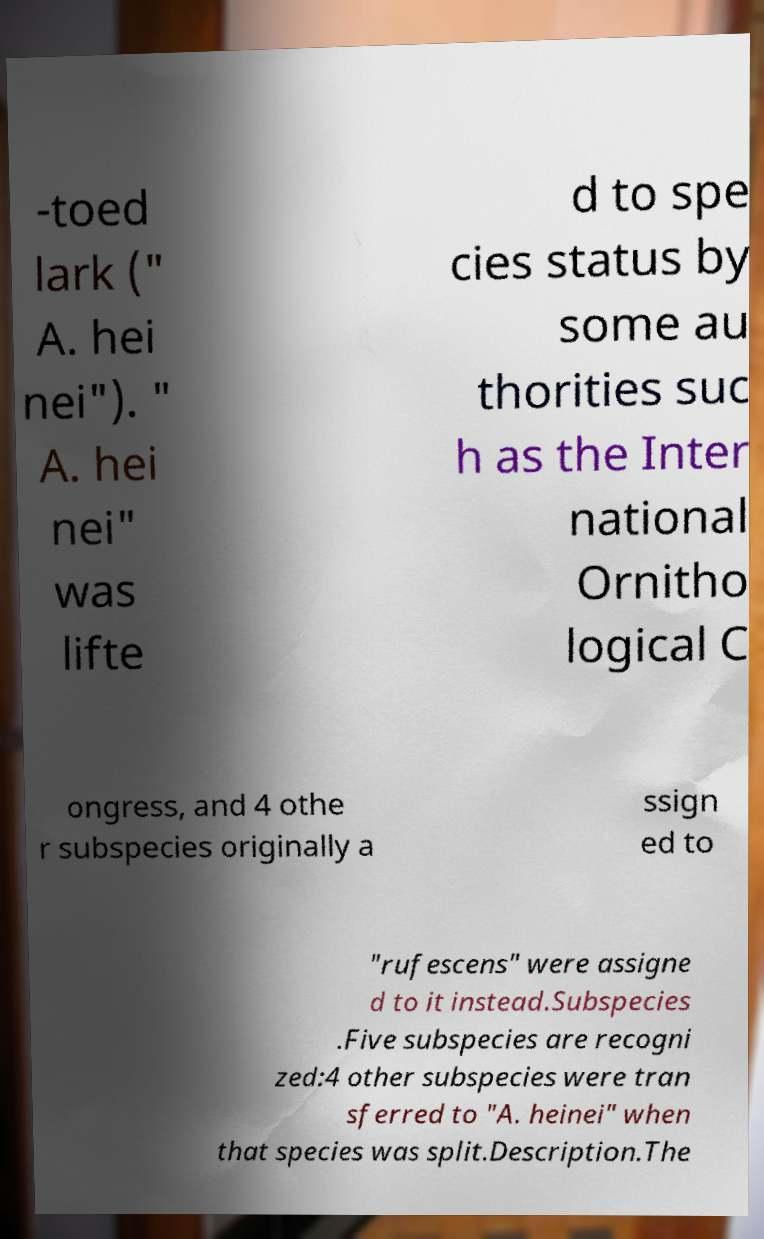Can you read and provide the text displayed in the image?This photo seems to have some interesting text. Can you extract and type it out for me? -toed lark (" A. hei nei"). " A. hei nei" was lifte d to spe cies status by some au thorities suc h as the Inter national Ornitho logical C ongress, and 4 othe r subspecies originally a ssign ed to "rufescens" were assigne d to it instead.Subspecies .Five subspecies are recogni zed:4 other subspecies were tran sferred to "A. heinei" when that species was split.Description.The 